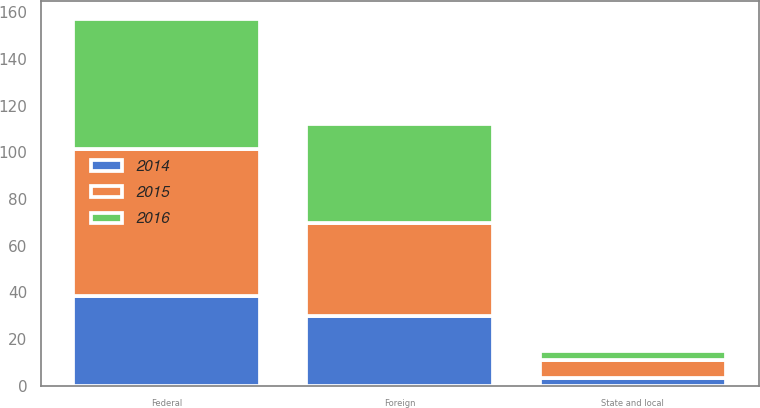Convert chart. <chart><loc_0><loc_0><loc_500><loc_500><stacked_bar_chart><ecel><fcel>Federal<fcel>State and local<fcel>Foreign<nl><fcel>2016<fcel>55.7<fcel>4.1<fcel>42.5<nl><fcel>2015<fcel>63.1<fcel>7.6<fcel>40<nl><fcel>2014<fcel>38.4<fcel>3.3<fcel>29.8<nl></chart> 